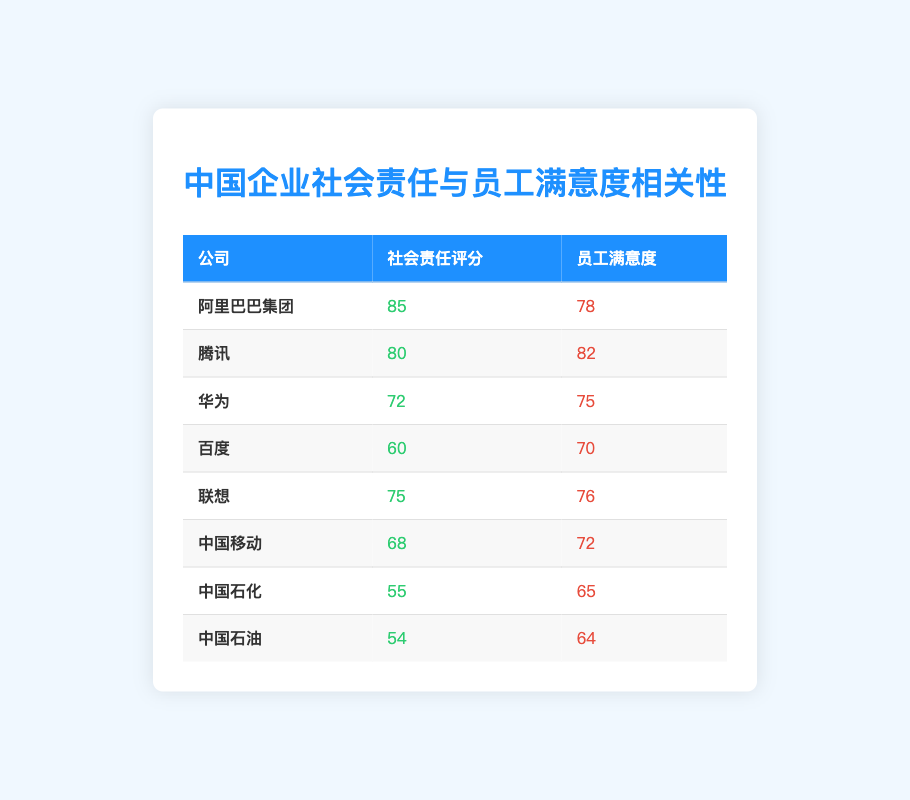What is the corporate social responsibility rating of Tencent? From the table, the row corresponding to Tencent shows a social responsibility rating of 80.
Answer: 80 Which corporation has the highest employee satisfaction? Looking through the employee satisfaction values in the table, Tencent has the highest satisfaction score of 82.
Answer: Tencent What is the difference in employee satisfaction between Alibaba Group and Huawei? Employee satisfaction for Alibaba Group is 78 and for Huawei it's 75, so the difference is 78 - 75 = 3.
Answer: 3 Are the employee satisfaction levels of Sinopec and PetroChina equal? The employee satisfaction level for Sinopec is 65, while for PetroChina, it is 64. Since 65 is not equal to 64, they are not equal.
Answer: No What is the average corporate social responsibility rating for the companies listed? To find the average CSR rating, sum all the CSR ratings: 85 + 80 + 72 + 60 + 75 + 68 + 55 + 54 =  599. There are 8 companies, so the average is 599 / 8 = 74.875, which we can round to 75.
Answer: 75 Which company has a CSR rating below 70 and what is its employee satisfaction? Upon examining the CSR ratings, both Baidu (60) and Sinopec (55) have ratings below 70. Their employee satisfaction ratings are 70 and 65, respectively. Thus, these two are the valid answers.
Answer: Baidu (70) and Sinopec (65) What is the total employee satisfaction score among all corporations? Summing the employee satisfaction scores: 78 + 82 + 75 + 70 + 76 + 72 + 65 + 64 = 492.
Answer: 492 Which corporation has a social responsibility rating equal to 55? From the table, Sinopec has a CSR rating of 55.
Answer: Sinopec If we order the corporate social responsibility ratings from highest to lowest, what would be the rating of the third corporation? The CSR ratings in order from highest to lowest are 85, 80, 75, 72, 68, 60, 55, and 54. The third rating is 75, associated with Lenovo.
Answer: 75 